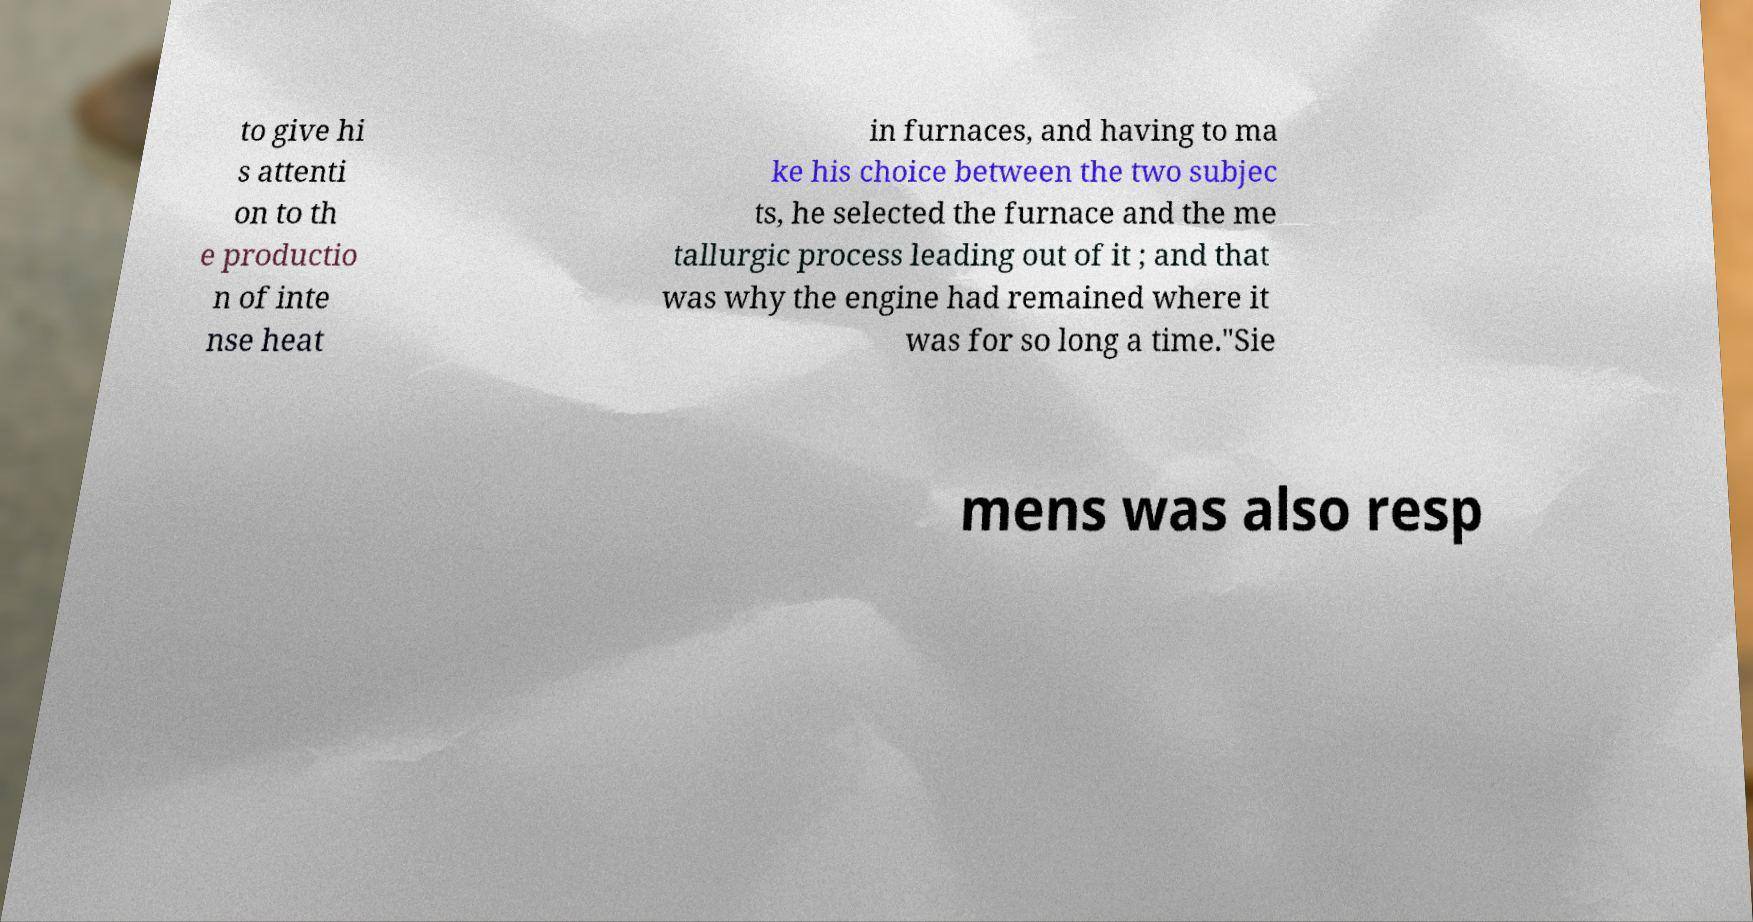Could you assist in decoding the text presented in this image and type it out clearly? to give hi s attenti on to th e productio n of inte nse heat in furnaces, and having to ma ke his choice between the two subjec ts, he selected the furnace and the me tallurgic process leading out of it ; and that was why the engine had remained where it was for so long a time."Sie mens was also resp 